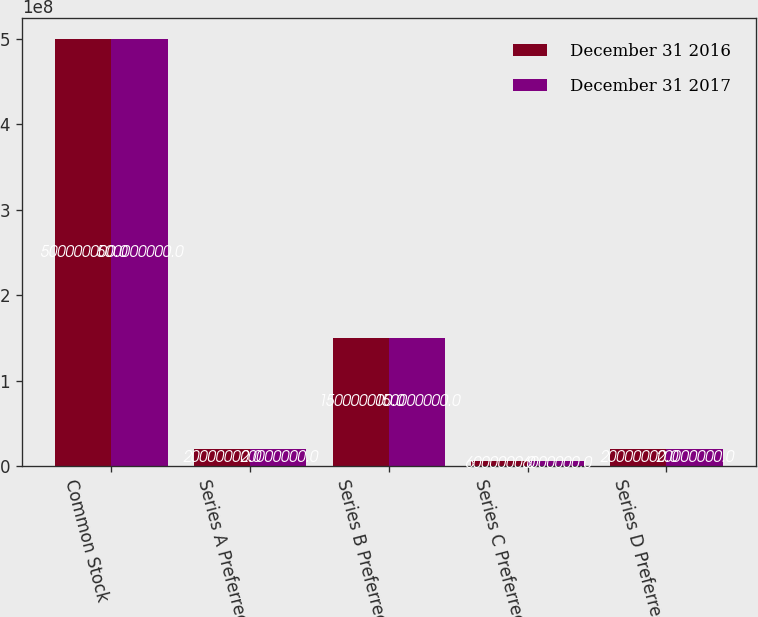<chart> <loc_0><loc_0><loc_500><loc_500><stacked_bar_chart><ecel><fcel>Common Stock<fcel>Series A Preferred<fcel>Series B Preferred<fcel>Series C Preferred<fcel>Series D Preferred<nl><fcel>December 31 2016<fcel>5e+08<fcel>2e+07<fcel>1.5e+08<fcel>6e+06<fcel>2e+07<nl><fcel>December 31 2017<fcel>5e+08<fcel>2e+07<fcel>1.5e+08<fcel>6e+06<fcel>2e+07<nl></chart> 